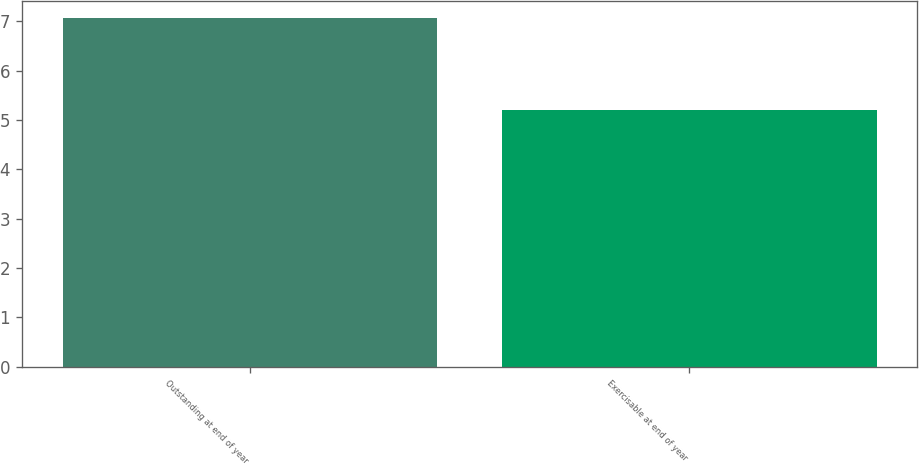Convert chart to OTSL. <chart><loc_0><loc_0><loc_500><loc_500><bar_chart><fcel>Outstanding at end of year<fcel>Exercisable at end of year<nl><fcel>7.06<fcel>5.21<nl></chart> 